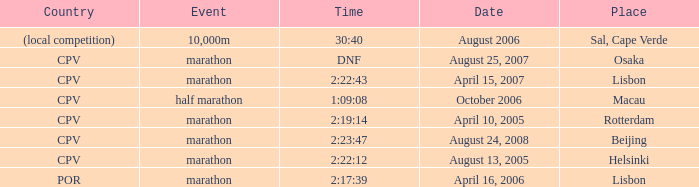What is the Country of the 10,000m Event? (local competition). 